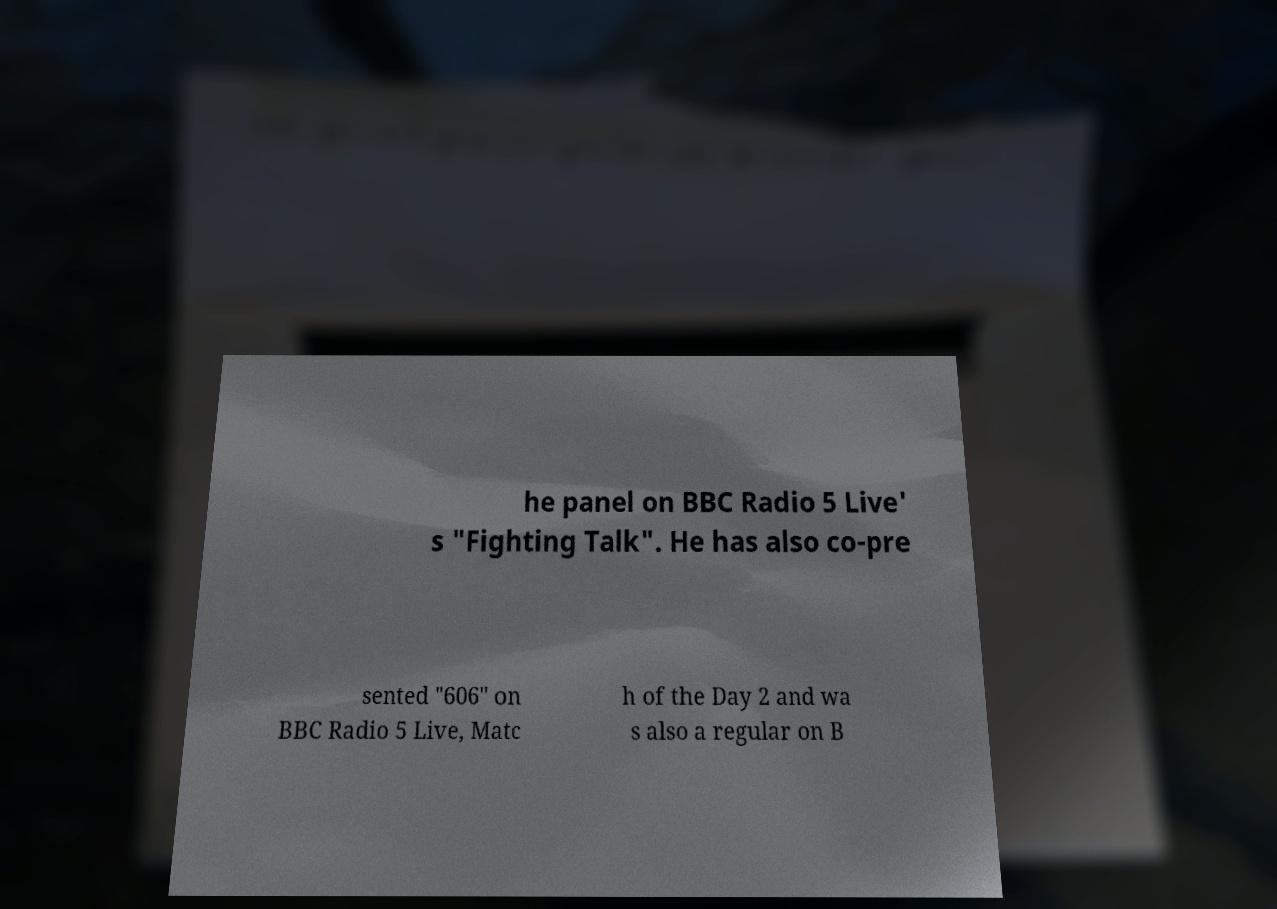Can you read and provide the text displayed in the image?This photo seems to have some interesting text. Can you extract and type it out for me? he panel on BBC Radio 5 Live' s "Fighting Talk". He has also co-pre sented "606" on BBC Radio 5 Live, Matc h of the Day 2 and wa s also a regular on B 